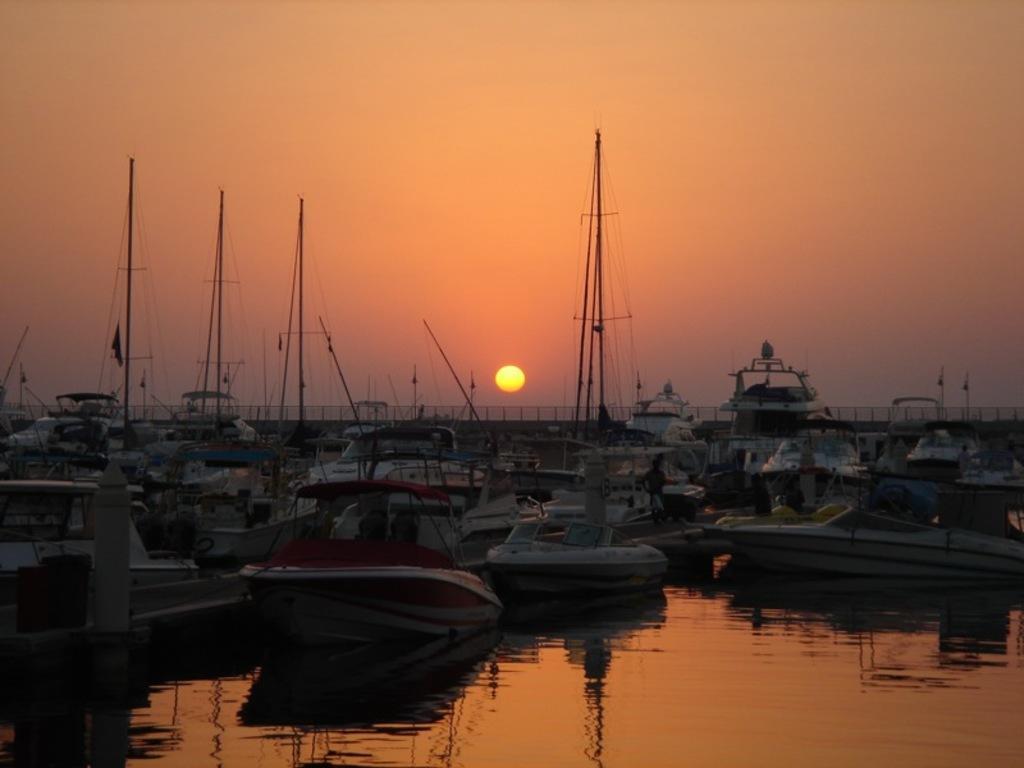Please provide a concise description of this image. In this image there is the lake, on which there are some boats, at the top there is the sky, sun. 